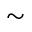<formula> <loc_0><loc_0><loc_500><loc_500>\sim</formula> 